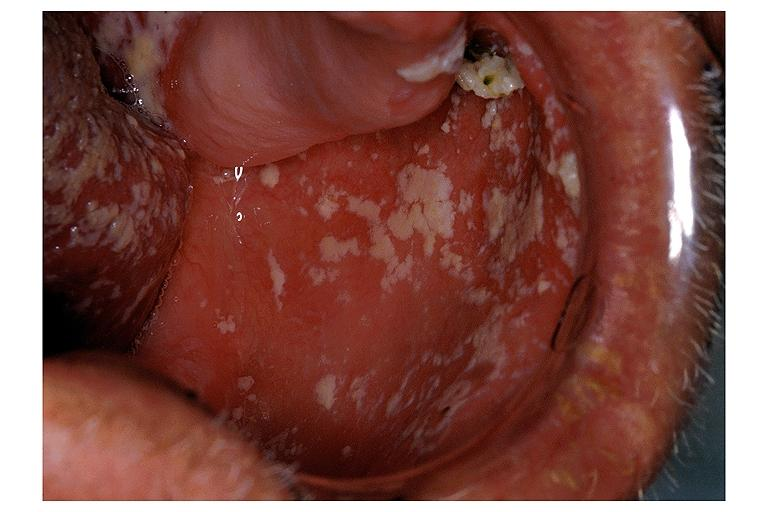what does this image show?
Answer the question using a single word or phrase. Candidiasis-pseudomembraneous 